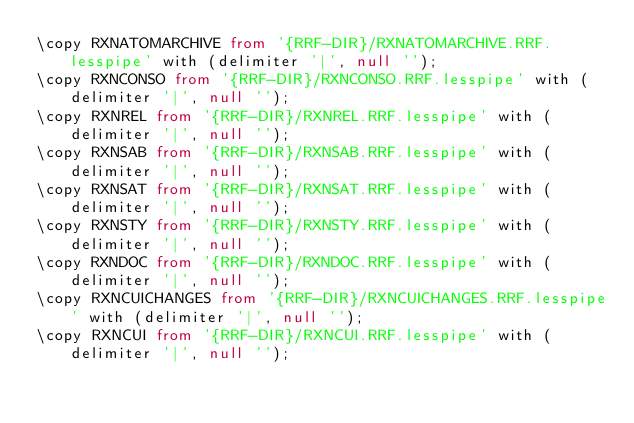<code> <loc_0><loc_0><loc_500><loc_500><_SQL_>\copy RXNATOMARCHIVE from '{RRF-DIR}/RXNATOMARCHIVE.RRF.lesspipe' with (delimiter '|', null '');
\copy RXNCONSO from '{RRF-DIR}/RXNCONSO.RRF.lesspipe' with (delimiter '|', null '');
\copy RXNREL from '{RRF-DIR}/RXNREL.RRF.lesspipe' with (delimiter '|', null '');
\copy RXNSAB from '{RRF-DIR}/RXNSAB.RRF.lesspipe' with (delimiter '|', null '');
\copy RXNSAT from '{RRF-DIR}/RXNSAT.RRF.lesspipe' with (delimiter '|', null '');
\copy RXNSTY from '{RRF-DIR}/RXNSTY.RRF.lesspipe' with (delimiter '|', null '');
\copy RXNDOC from '{RRF-DIR}/RXNDOC.RRF.lesspipe' with (delimiter '|', null '');
\copy RXNCUICHANGES from '{RRF-DIR}/RXNCUICHANGES.RRF.lesspipe' with (delimiter '|', null '');
\copy RXNCUI from '{RRF-DIR}/RXNCUI.RRF.lesspipe' with (delimiter '|', null '');</code> 